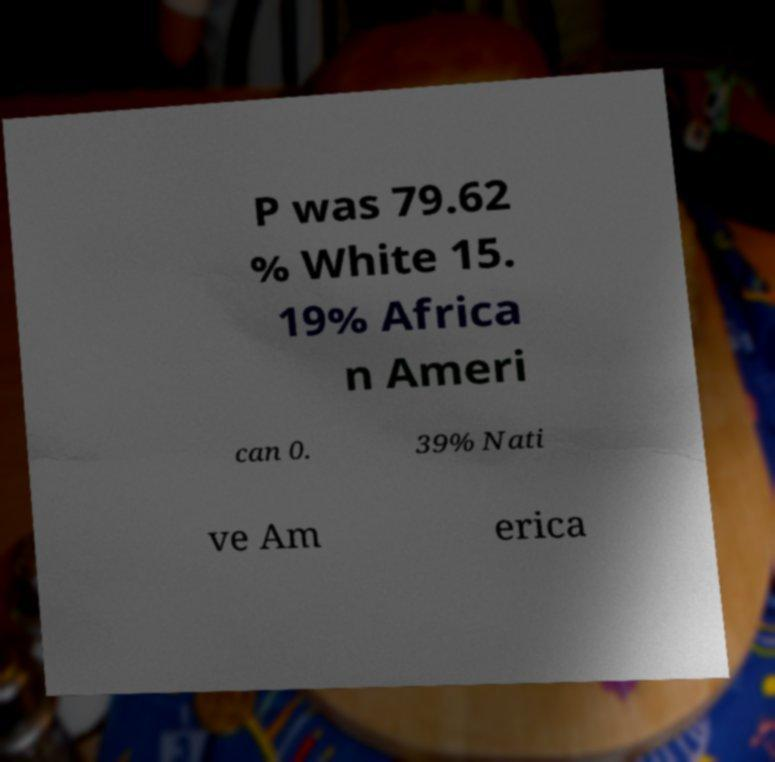There's text embedded in this image that I need extracted. Can you transcribe it verbatim? P was 79.62 % White 15. 19% Africa n Ameri can 0. 39% Nati ve Am erica 